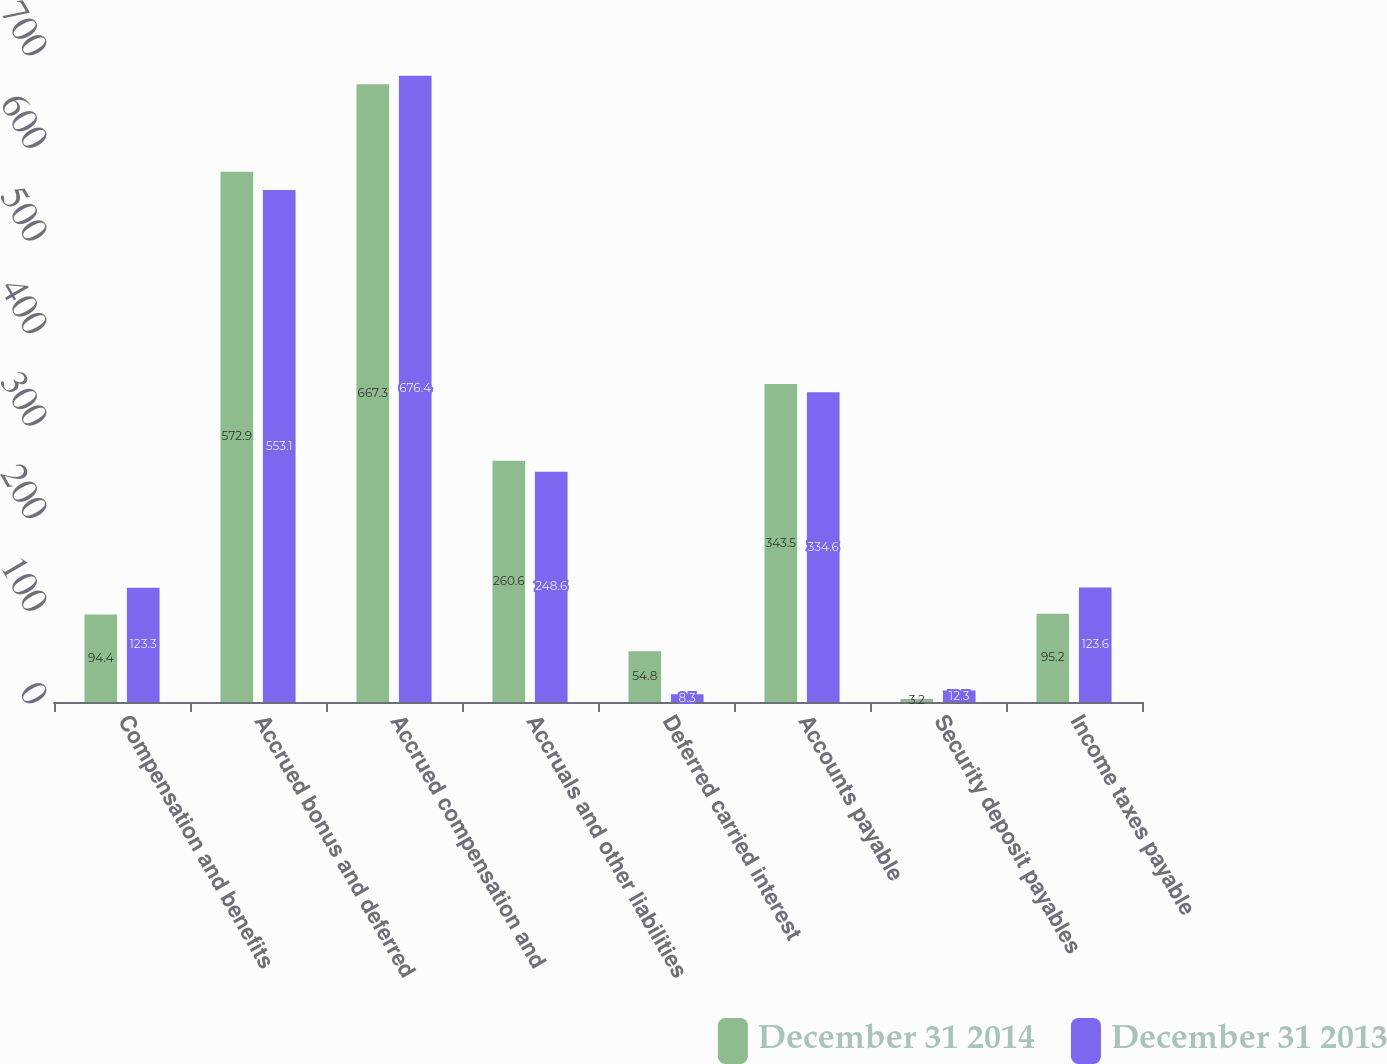Convert chart to OTSL. <chart><loc_0><loc_0><loc_500><loc_500><stacked_bar_chart><ecel><fcel>Compensation and benefits<fcel>Accrued bonus and deferred<fcel>Accrued compensation and<fcel>Accruals and other liabilities<fcel>Deferred carried interest<fcel>Accounts payable<fcel>Security deposit payables<fcel>Income taxes payable<nl><fcel>December 31 2014<fcel>94.4<fcel>572.9<fcel>667.3<fcel>260.6<fcel>54.8<fcel>343.5<fcel>3.2<fcel>95.2<nl><fcel>December 31 2013<fcel>123.3<fcel>553.1<fcel>676.4<fcel>248.6<fcel>8.3<fcel>334.6<fcel>12.3<fcel>123.6<nl></chart> 